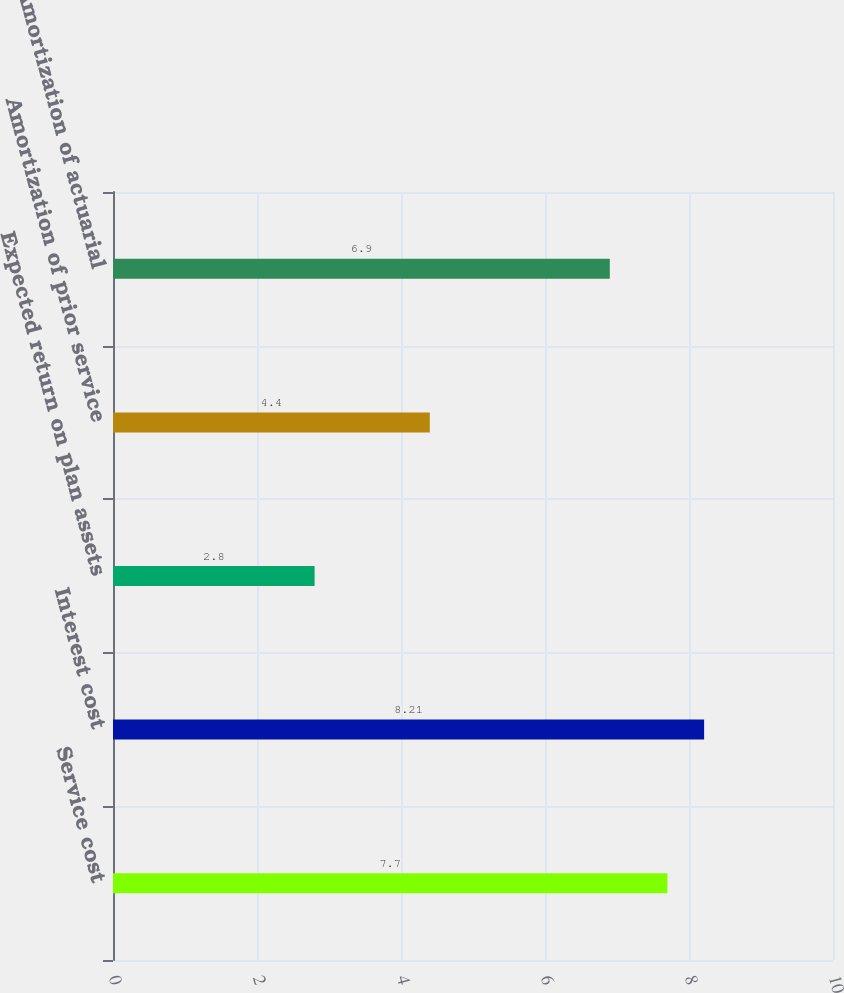Convert chart. <chart><loc_0><loc_0><loc_500><loc_500><bar_chart><fcel>Service cost<fcel>Interest cost<fcel>Expected return on plan assets<fcel>Amortization of prior service<fcel>Amortization of actuarial<nl><fcel>7.7<fcel>8.21<fcel>2.8<fcel>4.4<fcel>6.9<nl></chart> 